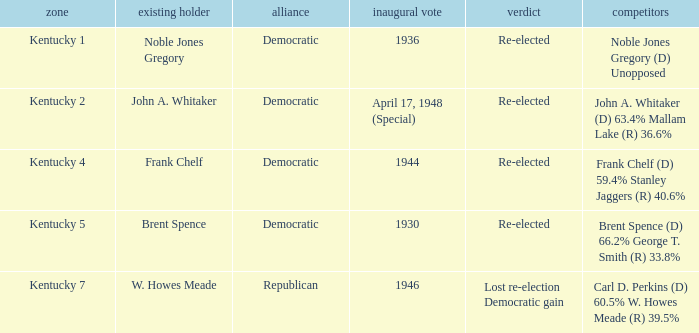List all candidates in the democratic party where the election had the incumbent Frank Chelf running. Frank Chelf (D) 59.4% Stanley Jaggers (R) 40.6%. 